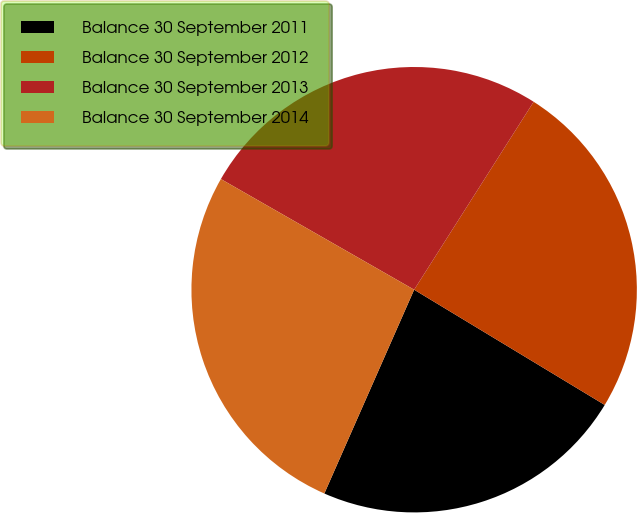<chart> <loc_0><loc_0><loc_500><loc_500><pie_chart><fcel>Balance 30 September 2011<fcel>Balance 30 September 2012<fcel>Balance 30 September 2013<fcel>Balance 30 September 2014<nl><fcel>22.95%<fcel>24.64%<fcel>25.74%<fcel>26.67%<nl></chart> 